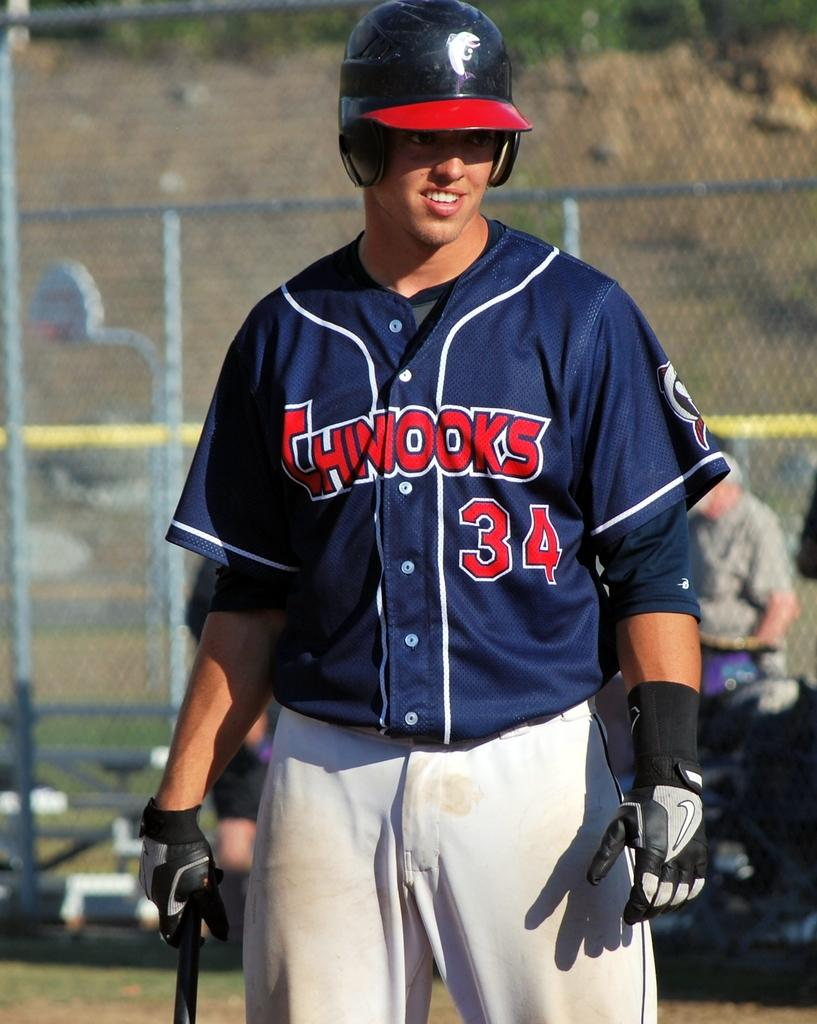What is the main subject of the image? There is a man standing in the middle of the image. What is the man holding in the image? The man is holding a baseball bat. What can be seen behind the man? There is a fencing behind the man. What is happening behind the fencing? There are people standing and sitting behind the fencing. What is visible in the background beyond the fencing? There is a hill visible behind the fencing. What type of tax is being discussed by the people behind the fencing? There is no indication in the image that a tax discussion is taking place. --- Facts: 1. There is a car parked on the street in the image. 2. The car is red. 3. There are trees on both sides of the street. 4. The street is paved. 5. There is a sidewalk on one side of the street. Absurd Topics: parrot, ocean, dance Conversation: What is the main subject of the image? There is a car parked on the street in the image. What color is the car? The car is red. What can be seen on both sides of the street? There are trees on both sides of the street. What is the surface of the street made of? The street is paved. Is there any pedestrian infrastructure visible in the image? Yes, there is a sidewalk on one side of the street. Reasoning: Let's think step by step in order to produce the conversation. We start by identifying the main subject of the image, which is the car parked on the street. Then, we describe the color of the car, which is red. Next, we mention the trees on both sides of the street and the paved surface. Finally, we describe the presence of a sidewalk, which is a pedestrian infrastructure. Each question is designed to elicit a specific detail about the image that is known from the provided facts. Absurd Question/Answer: Can you see a parrot flying over the ocean in the image? There is no ocean or parrot present in the image; it features a red car parked on a paved street with trees and a sidewalk. 